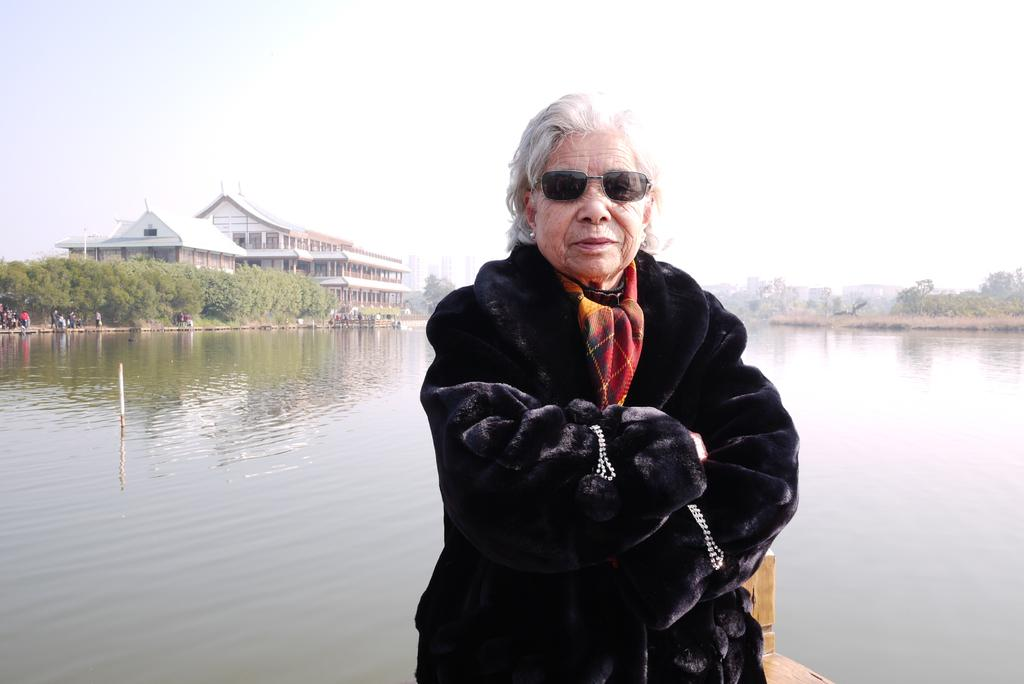What is the main subject of the image? There is a woman standing in the middle of the image. What is the woman's expression in the image? The woman is smiling. What can be seen behind the woman in the image? There is water, trees, and buildings visible behind the woman. What is visible at the top of the image? Clouds and the sky are visible at the top of the image. What type of square can be seen in the image? There is no square present in the image. What holiday is the woman celebrating in the image? There is no indication of a holiday in the image. 